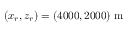Convert formula to latex. <formula><loc_0><loc_0><loc_500><loc_500>( x _ { r } , z _ { r } ) = ( 4 0 0 0 , 2 0 0 0 ) m</formula> 